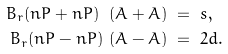Convert formula to latex. <formula><loc_0><loc_0><loc_500><loc_500>B _ { r } ( n P + n P ) \ ( A + A ) & \ = \ s , \\ B _ { r } ( n P - n P ) \ ( A - A ) & \ = \ 2 d .</formula> 